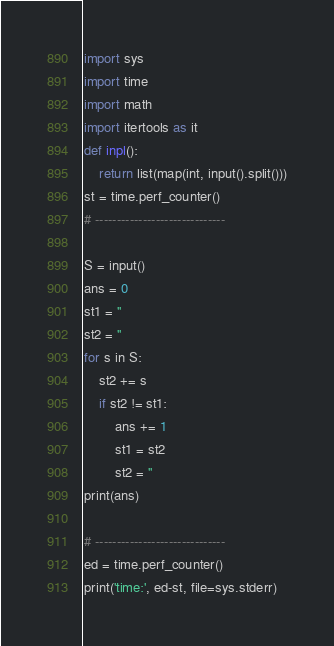<code> <loc_0><loc_0><loc_500><loc_500><_Python_>import sys
import time
import math
import itertools as it
def inpl():
    return list(map(int, input().split()))
st = time.perf_counter()
# ------------------------------

S = input()
ans = 0
st1 = ''
st2 = ''
for s in S:
	st2 += s
	if st2 != st1:
		ans += 1
		st1 = st2
		st2 = ''
print(ans)

# ------------------------------
ed = time.perf_counter()
print('time:', ed-st, file=sys.stderr)
</code> 